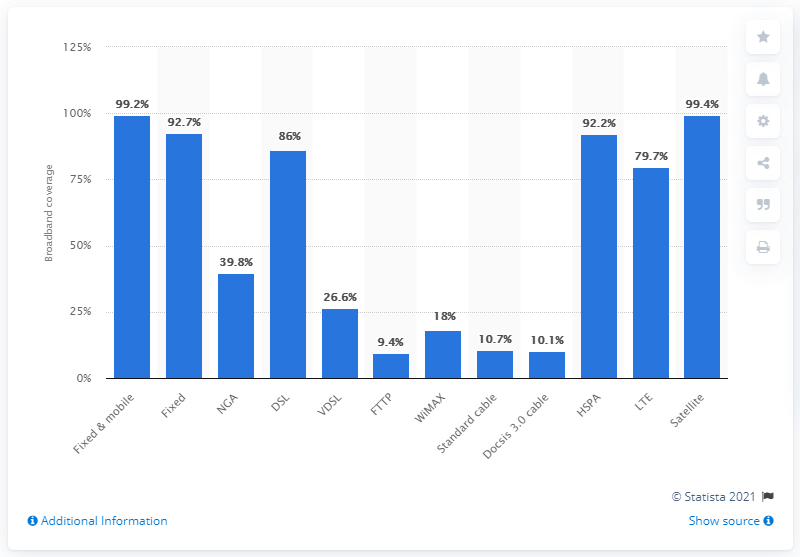Draw attention to some important aspects in this diagram. In 2016, the total NGA coverage in rural areas of Europe was 39.8%. 